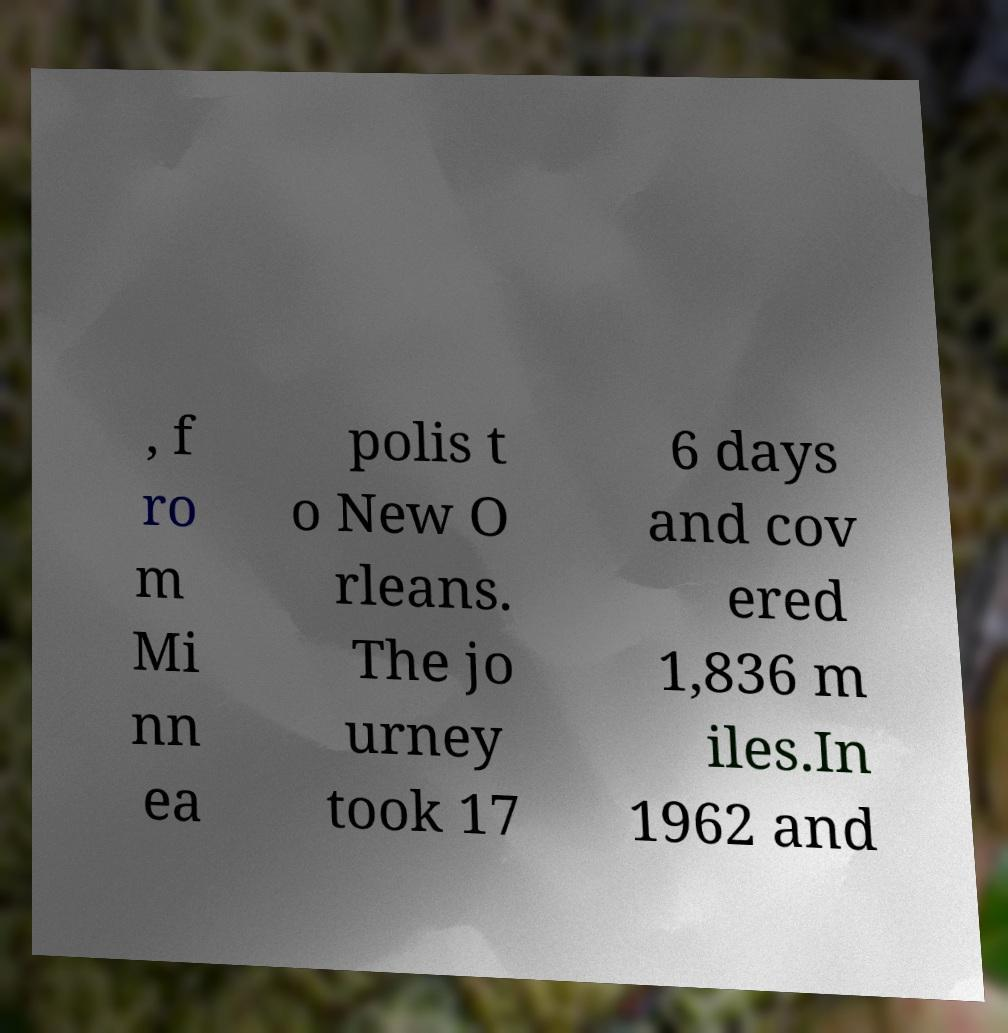There's text embedded in this image that I need extracted. Can you transcribe it verbatim? , f ro m Mi nn ea polis t o New O rleans. The jo urney took 17 6 days and cov ered 1,836 m iles.In 1962 and 